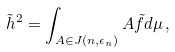<formula> <loc_0><loc_0><loc_500><loc_500>\tilde { h } ^ { 2 } = \int _ { A \in J ( n , \epsilon _ { n } ) } A \tilde { f } d \mu \, ,</formula> 